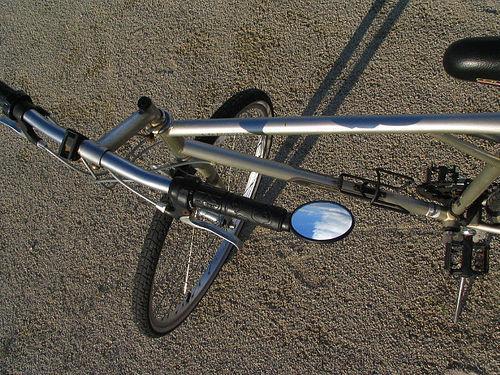How many wheels does this have?
Give a very brief answer. 2. 